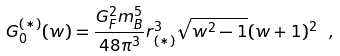Convert formula to latex. <formula><loc_0><loc_0><loc_500><loc_500>G _ { 0 } ^ { ( \ast ) } ( w ) = \frac { G _ { F } ^ { 2 } m _ { B } ^ { 5 } } { 4 8 \pi ^ { 3 } } r _ { ( \ast ) } ^ { 3 } \sqrt { w ^ { 2 } - 1 } ( w + 1 ) ^ { 2 } \ ,</formula> 